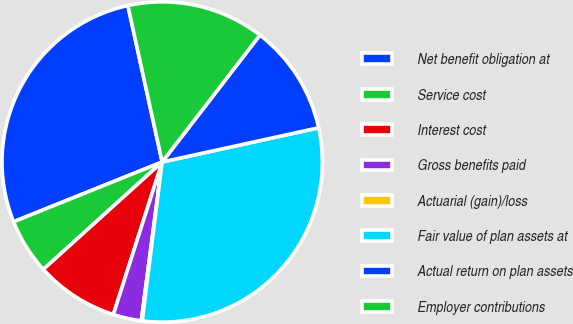<chart> <loc_0><loc_0><loc_500><loc_500><pie_chart><fcel>Net benefit obligation at<fcel>Service cost<fcel>Interest cost<fcel>Gross benefits paid<fcel>Actuarial (gain)/loss<fcel>Fair value of plan assets at<fcel>Actual return on plan assets<fcel>Employer contributions<nl><fcel>27.65%<fcel>5.61%<fcel>8.37%<fcel>2.85%<fcel>0.1%<fcel>30.41%<fcel>11.13%<fcel>13.88%<nl></chart> 